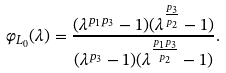Convert formula to latex. <formula><loc_0><loc_0><loc_500><loc_500>\varphi _ { L _ { 0 } } ( \lambda ) = \frac { ( \lambda ^ { p _ { 1 } p _ { 3 } } - 1 ) ( \lambda ^ { \frac { p _ { 3 } } { p _ { 2 } } } - 1 ) } { ( \lambda ^ { p _ { 3 } } - 1 ) ( \lambda ^ { \frac { p _ { 1 } p _ { 3 } } { p _ { 2 } } } - 1 ) } .</formula> 